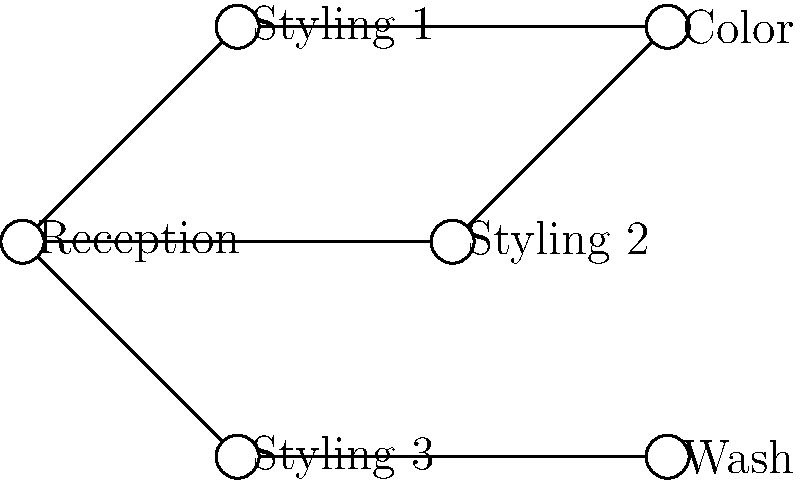In the network topology diagram of your aunt's beauty salon, which station has the highest degree (most direct connections)? To determine which station has the highest degree in the network topology diagram, we need to count the number of direct connections for each station:

1. Reception: Connected to Styling 1, Styling 2, and Styling 3 (3 connections)
2. Styling 1: Connected to Reception and Color (2 connections)
3. Styling 2: Connected to Reception and Color (2 connections)
4. Styling 3: Connected to Reception and Wash (2 connections)
5. Color: Connected to Styling 1 and Styling 2 (2 connections)
6. Wash: Connected to Styling 3 (1 connection)

After counting the connections for each station, we can see that the Reception has the highest number of direct connections with 3, making it the station with the highest degree in the network topology.
Answer: Reception 